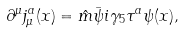<formula> <loc_0><loc_0><loc_500><loc_500>\partial ^ { \mu } j ^ { a } _ { \mu } ( x ) = \hat { m } \bar { \psi } i \gamma _ { 5 } \tau ^ { a } \psi ( x ) ,</formula> 